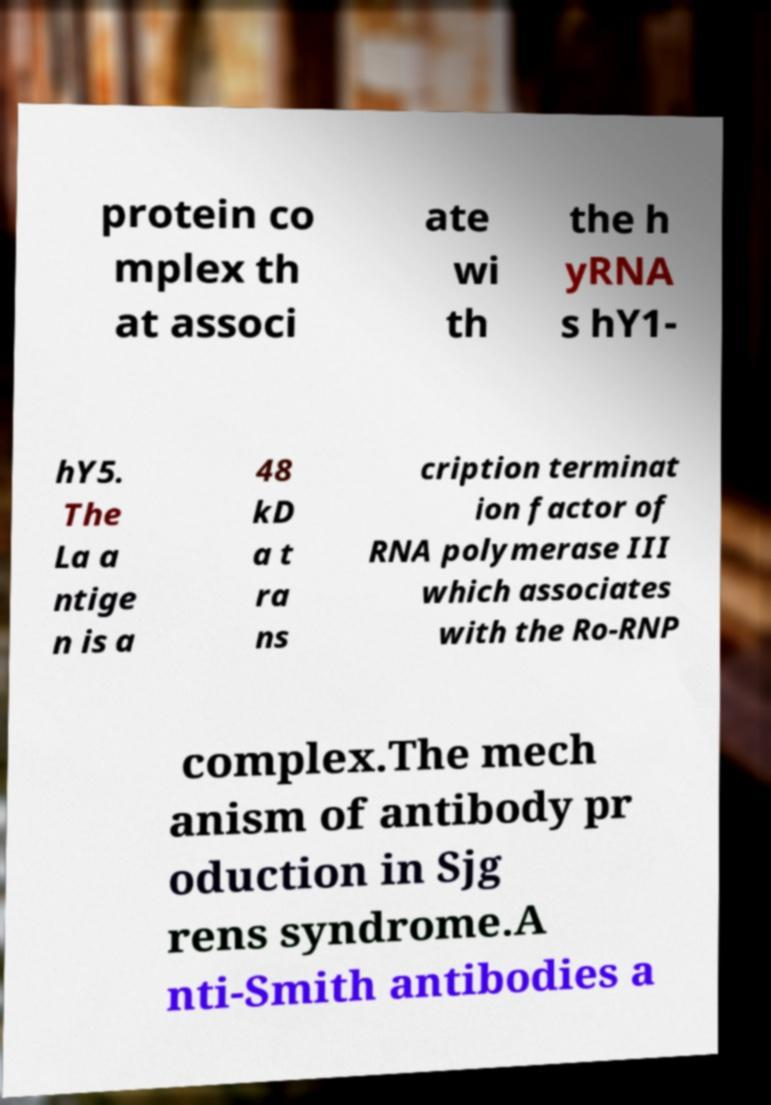Please identify and transcribe the text found in this image. protein co mplex th at associ ate wi th the h yRNA s hY1- hY5. The La a ntige n is a 48 kD a t ra ns cription terminat ion factor of RNA polymerase III which associates with the Ro-RNP complex.The mech anism of antibody pr oduction in Sjg rens syndrome.A nti-Smith antibodies a 